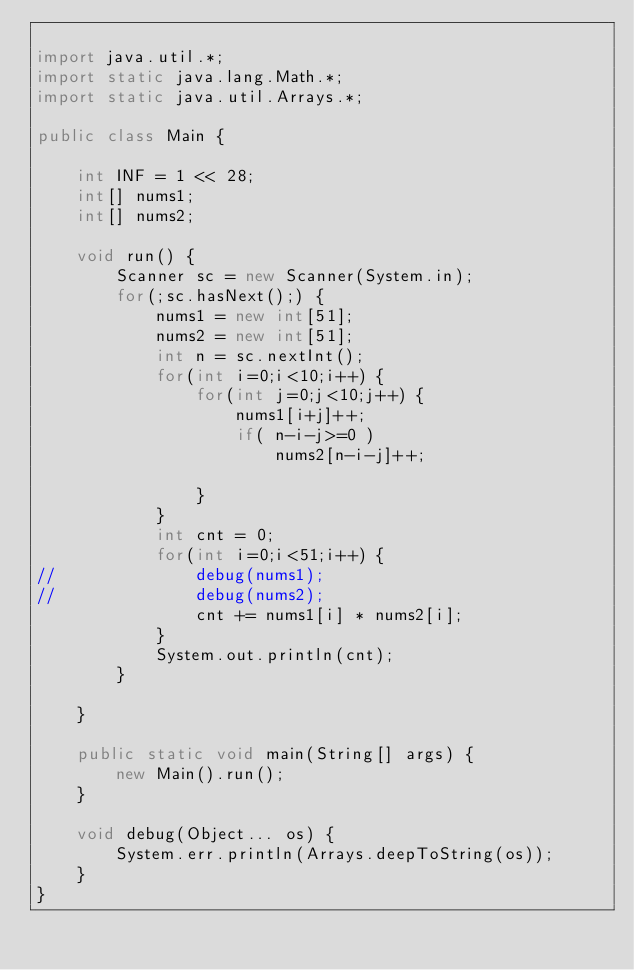Convert code to text. <code><loc_0><loc_0><loc_500><loc_500><_Java_>
import java.util.*;
import static java.lang.Math.*;
import static java.util.Arrays.*;

public class Main {

	int INF = 1 << 28;
	int[] nums1;
	int[] nums2;
	
	void run() {
		Scanner sc = new Scanner(System.in);
		for(;sc.hasNext();) {
			nums1 = new int[51];
			nums2 = new int[51];
			int n = sc.nextInt();
			for(int i=0;i<10;i++) {
				for(int j=0;j<10;j++) {
					nums1[i+j]++;
					if( n-i-j>=0 )
						nums2[n-i-j]++;
					
				}
			}
			int cnt = 0;
			for(int i=0;i<51;i++) {
//				debug(nums1);
//				debug(nums2);
				cnt += nums1[i] * nums2[i];
			}
			System.out.println(cnt);
		}

	}

	public static void main(String[] args) {
		new Main().run();
	}

	void debug(Object... os) {
		System.err.println(Arrays.deepToString(os));
	}
}</code> 